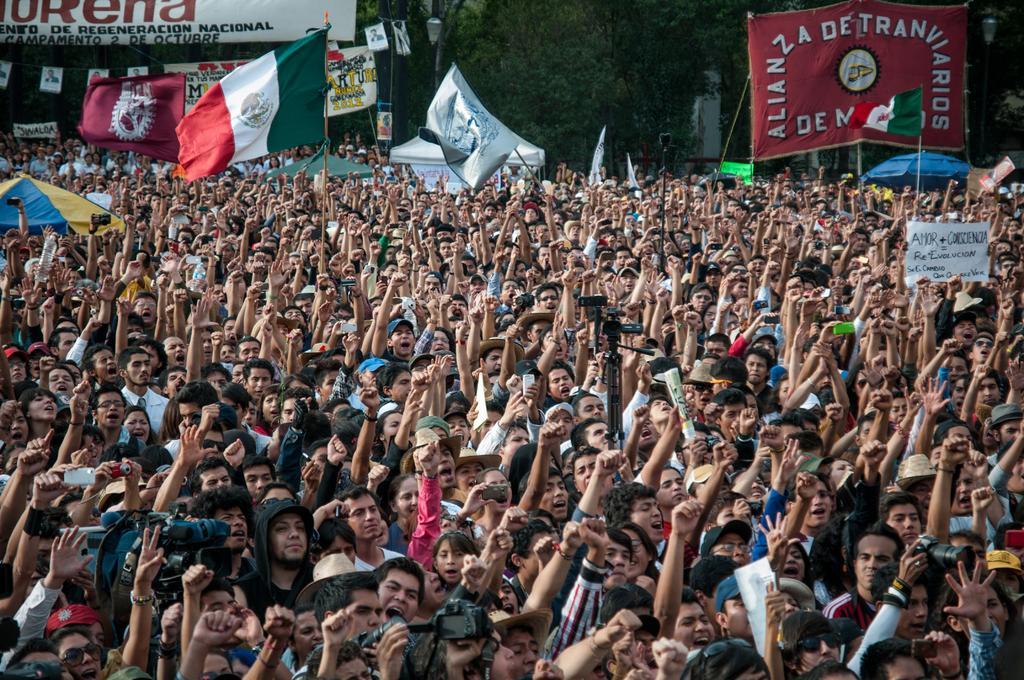Can you describe this image briefly? In the picture there is a huge crowd, all of them are raising their hands up and there are few flags, in the background there is a big banner and behind the banner there are trees. 